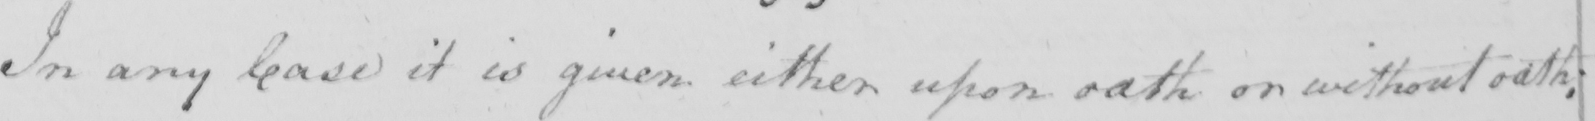Transcribe the text shown in this historical manuscript line. In any Case it is given either upon oath or without oath . 